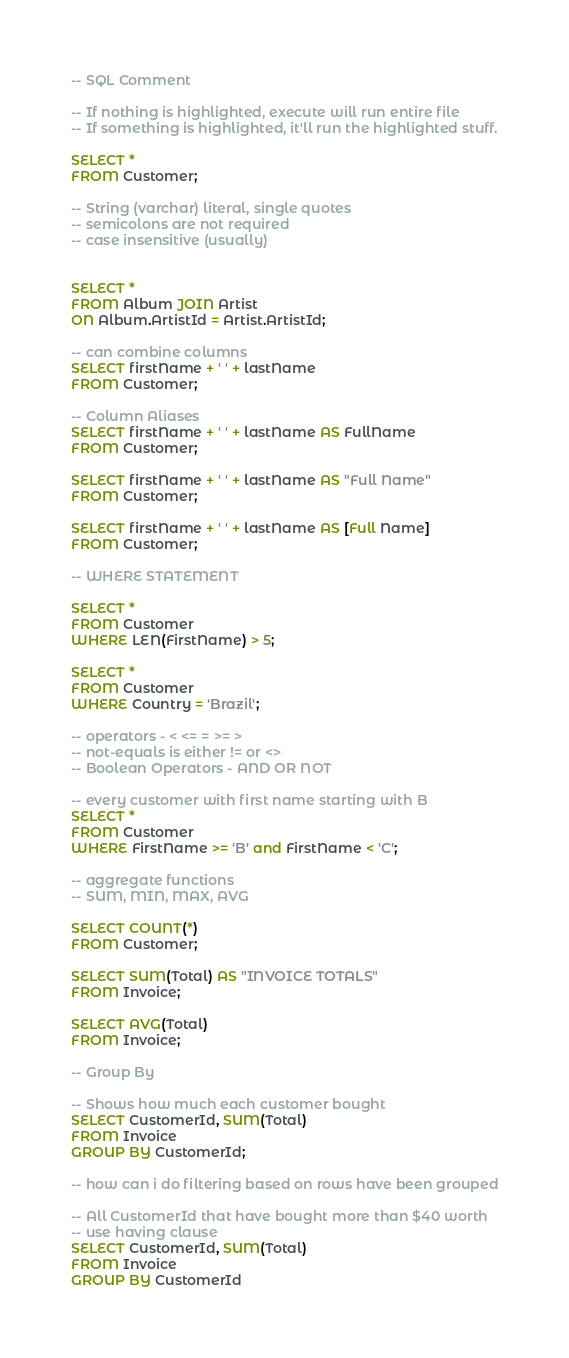Convert code to text. <code><loc_0><loc_0><loc_500><loc_500><_SQL_>-- SQL Comment

-- If nothing is highlighted, execute will run entire file
-- If something is highlighted, it'll run the highlighted stuff.

SELECT *
FROM Customer;

-- String (varchar) literal, single quotes
-- semicolons are not required
-- case insensitive (usually)


SELECT *
FROM Album JOIN Artist
ON Album.ArtistId = Artist.ArtistId;

-- can combine columns
SELECT firstName + ' ' + lastName
FROM Customer;

-- Column Aliases
SELECT firstName + ' ' + lastName AS FullName
FROM Customer;

SELECT firstName + ' ' + lastName AS "Full Name"
FROM Customer;

SELECT firstName + ' ' + lastName AS [Full Name]
FROM Customer;

-- WHERE STATEMENT

SELECT *
FROM Customer
WHERE LEN(FirstName) > 5;

SELECT *
FROM Customer
WHERE Country = 'Brazil';

-- operators - < <= = >= >
-- not-equals is either != or <>
-- Boolean Operators - AND OR NOT

-- every customer with first name starting with B
SELECT *
FROM Customer
WHERE FirstName >= 'B' and FirstName < 'C';

-- aggregate functions
-- SUM, MIN, MAX, AVG

SELECT COUNT(*)
FROM Customer;

SELECT SUM(Total) AS "INVOICE TOTALS"
FROM Invoice;

SELECT AVG(Total)
FROM Invoice;

-- Group By

-- Shows how much each customer bought
SELECT CustomerId, SUM(Total)
FROM Invoice
GROUP BY CustomerId;

-- how can i do filtering based on rows have been grouped

-- All CustomerId that have bought more than $40 worth
-- use having clause
SELECT CustomerId, SUM(Total)
FROM Invoice
GROUP BY CustomerId</code> 